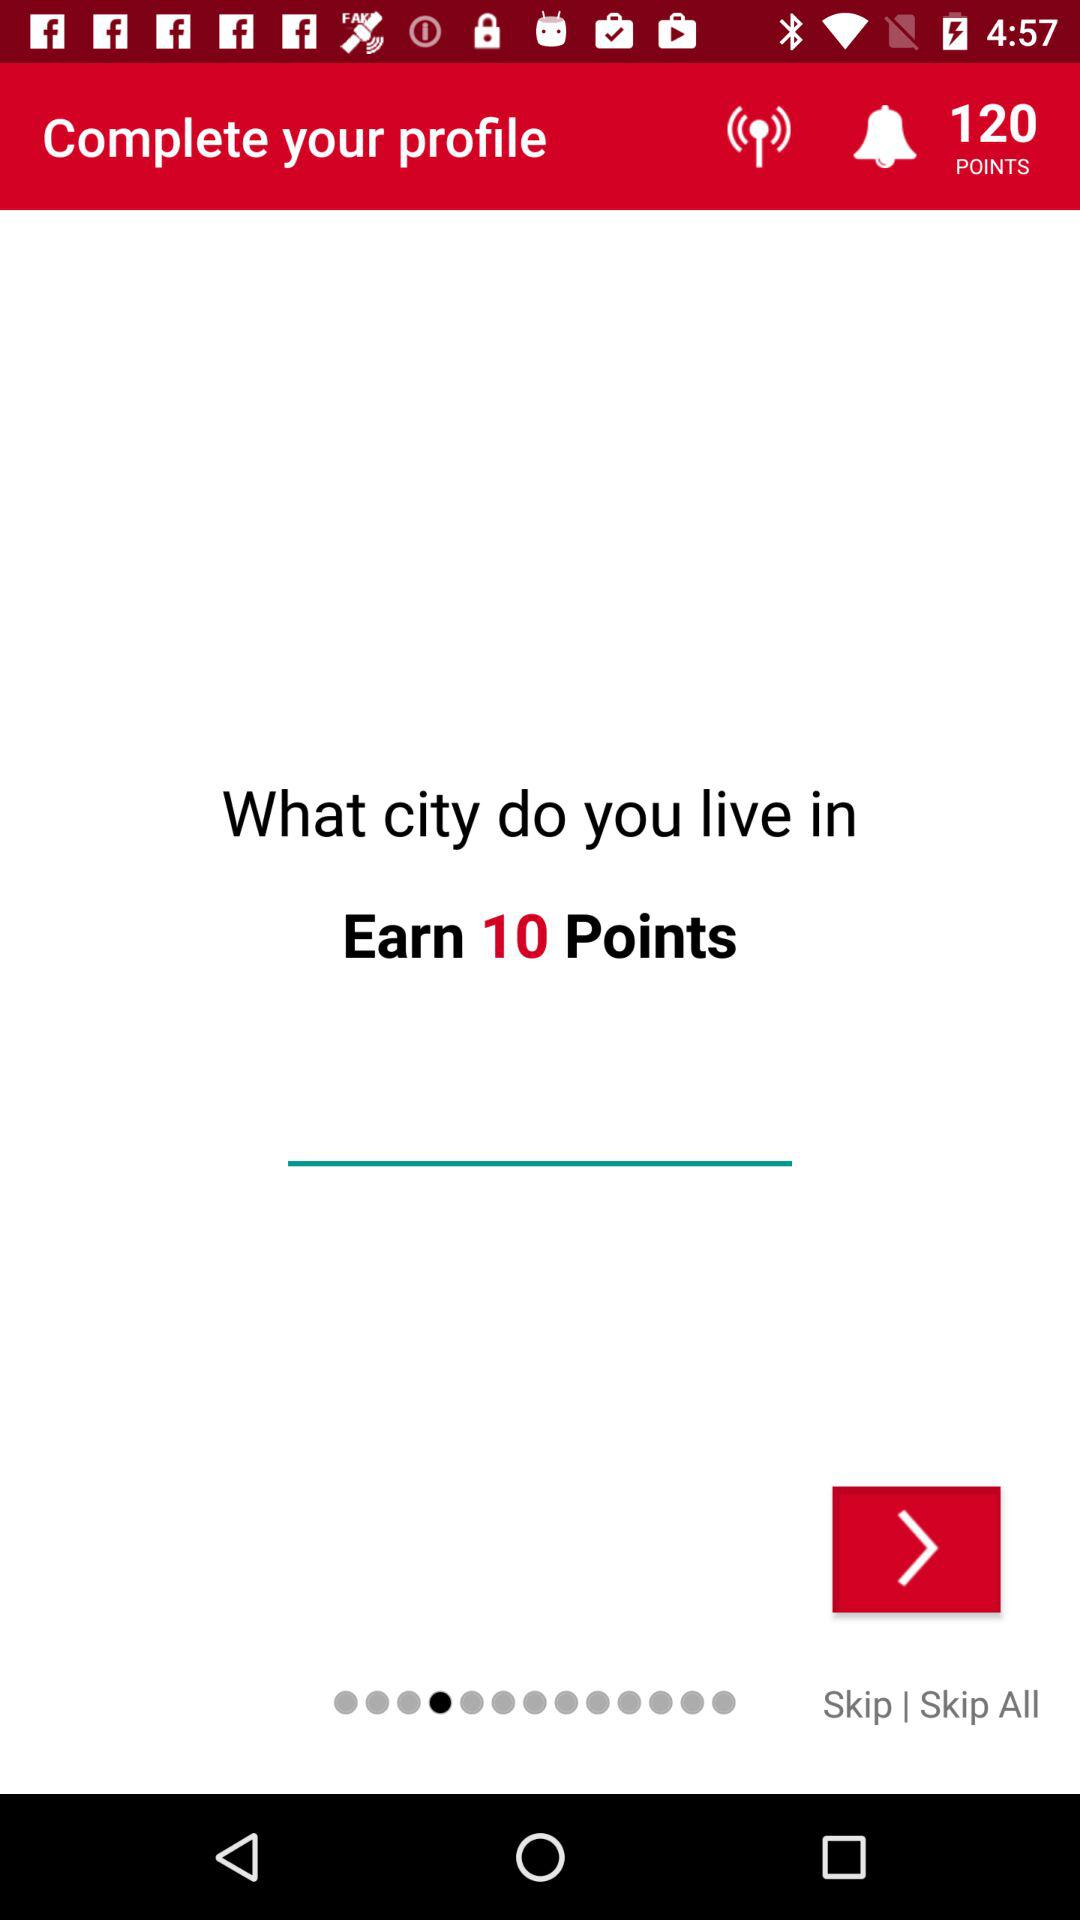How many points are available to earn?
Answer the question using a single word or phrase. 10 